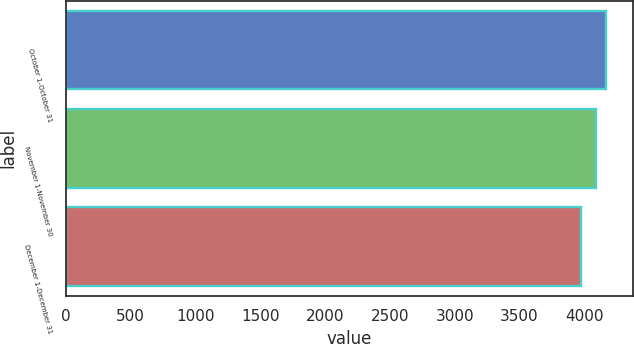Convert chart. <chart><loc_0><loc_0><loc_500><loc_500><bar_chart><fcel>October 1-October 31<fcel>November 1-November 30<fcel>December 1-December 31<nl><fcel>4169<fcel>4087<fcel>3970<nl></chart> 